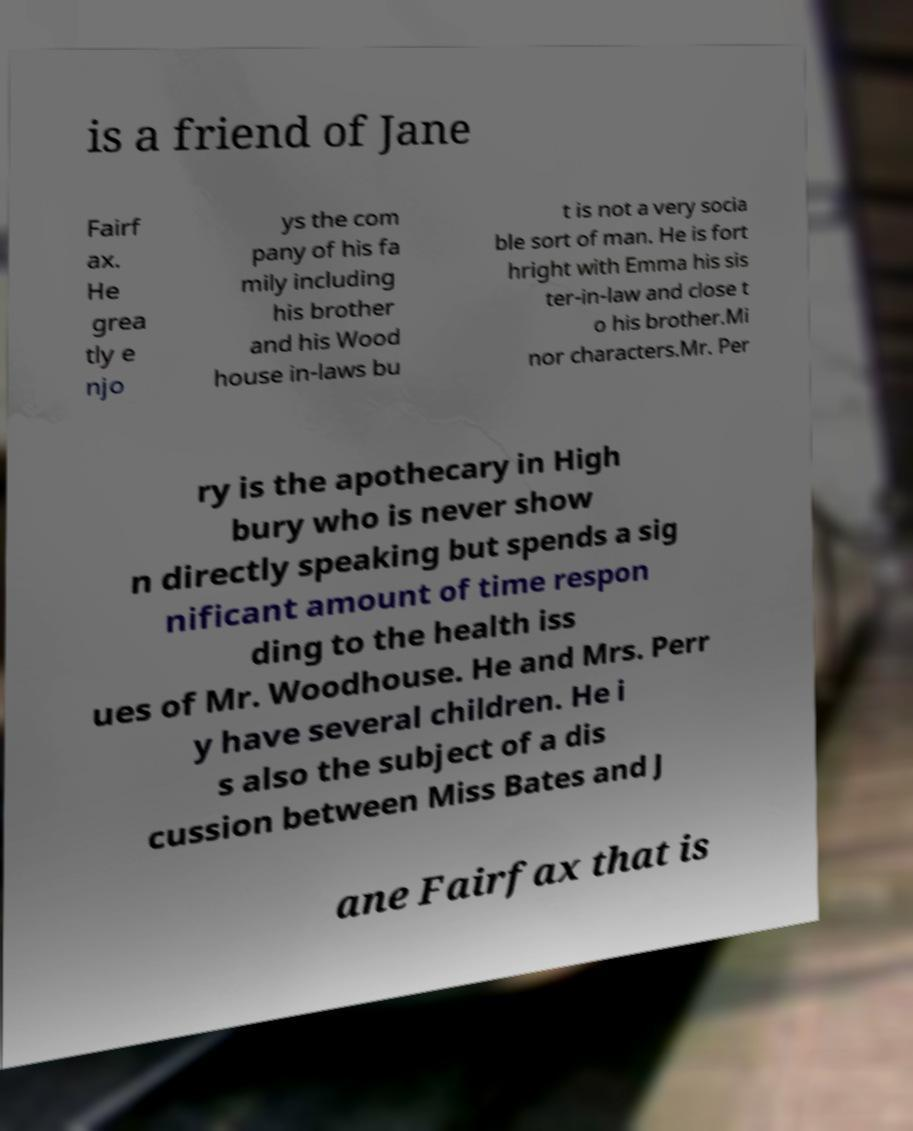Please read and relay the text visible in this image. What does it say? is a friend of Jane Fairf ax. He grea tly e njo ys the com pany of his fa mily including his brother and his Wood house in-laws bu t is not a very socia ble sort of man. He is fort hright with Emma his sis ter-in-law and close t o his brother.Mi nor characters.Mr. Per ry is the apothecary in High bury who is never show n directly speaking but spends a sig nificant amount of time respon ding to the health iss ues of Mr. Woodhouse. He and Mrs. Perr y have several children. He i s also the subject of a dis cussion between Miss Bates and J ane Fairfax that is 